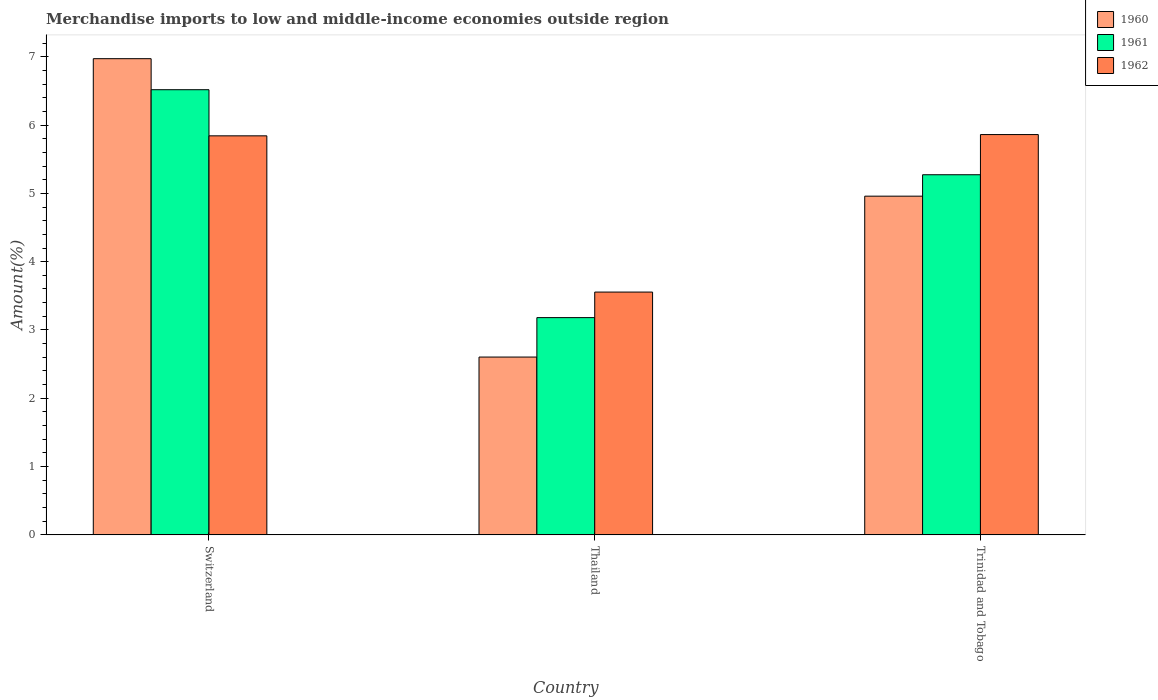How many bars are there on the 3rd tick from the right?
Ensure brevity in your answer.  3. What is the label of the 1st group of bars from the left?
Your answer should be compact. Switzerland. What is the percentage of amount earned from merchandise imports in 1960 in Thailand?
Ensure brevity in your answer.  2.6. Across all countries, what is the maximum percentage of amount earned from merchandise imports in 1960?
Keep it short and to the point. 6.97. Across all countries, what is the minimum percentage of amount earned from merchandise imports in 1962?
Your answer should be compact. 3.55. In which country was the percentage of amount earned from merchandise imports in 1960 maximum?
Your answer should be compact. Switzerland. In which country was the percentage of amount earned from merchandise imports in 1961 minimum?
Provide a succinct answer. Thailand. What is the total percentage of amount earned from merchandise imports in 1960 in the graph?
Make the answer very short. 14.53. What is the difference between the percentage of amount earned from merchandise imports in 1961 in Switzerland and that in Thailand?
Your answer should be compact. 3.34. What is the difference between the percentage of amount earned from merchandise imports in 1960 in Switzerland and the percentage of amount earned from merchandise imports in 1962 in Trinidad and Tobago?
Make the answer very short. 1.11. What is the average percentage of amount earned from merchandise imports in 1960 per country?
Ensure brevity in your answer.  4.84. What is the difference between the percentage of amount earned from merchandise imports of/in 1961 and percentage of amount earned from merchandise imports of/in 1962 in Thailand?
Your answer should be compact. -0.37. What is the ratio of the percentage of amount earned from merchandise imports in 1960 in Switzerland to that in Trinidad and Tobago?
Provide a succinct answer. 1.41. What is the difference between the highest and the second highest percentage of amount earned from merchandise imports in 1961?
Ensure brevity in your answer.  -2.09. What is the difference between the highest and the lowest percentage of amount earned from merchandise imports in 1962?
Give a very brief answer. 2.31. Is the sum of the percentage of amount earned from merchandise imports in 1962 in Thailand and Trinidad and Tobago greater than the maximum percentage of amount earned from merchandise imports in 1960 across all countries?
Keep it short and to the point. Yes. What does the 3rd bar from the left in Thailand represents?
Provide a short and direct response. 1962. Is it the case that in every country, the sum of the percentage of amount earned from merchandise imports in 1960 and percentage of amount earned from merchandise imports in 1962 is greater than the percentage of amount earned from merchandise imports in 1961?
Offer a very short reply. Yes. How many bars are there?
Offer a very short reply. 9. Are all the bars in the graph horizontal?
Provide a succinct answer. No. How many countries are there in the graph?
Your answer should be compact. 3. What is the difference between two consecutive major ticks on the Y-axis?
Your answer should be compact. 1. Does the graph contain any zero values?
Ensure brevity in your answer.  No. Where does the legend appear in the graph?
Provide a succinct answer. Top right. How many legend labels are there?
Ensure brevity in your answer.  3. How are the legend labels stacked?
Provide a short and direct response. Vertical. What is the title of the graph?
Provide a succinct answer. Merchandise imports to low and middle-income economies outside region. Does "1960" appear as one of the legend labels in the graph?
Your response must be concise. Yes. What is the label or title of the Y-axis?
Give a very brief answer. Amount(%). What is the Amount(%) of 1960 in Switzerland?
Provide a short and direct response. 6.97. What is the Amount(%) in 1961 in Switzerland?
Provide a short and direct response. 6.52. What is the Amount(%) of 1962 in Switzerland?
Offer a very short reply. 5.84. What is the Amount(%) of 1960 in Thailand?
Offer a terse response. 2.6. What is the Amount(%) in 1961 in Thailand?
Provide a succinct answer. 3.18. What is the Amount(%) of 1962 in Thailand?
Your answer should be very brief. 3.55. What is the Amount(%) in 1960 in Trinidad and Tobago?
Give a very brief answer. 4.96. What is the Amount(%) in 1961 in Trinidad and Tobago?
Offer a very short reply. 5.27. What is the Amount(%) in 1962 in Trinidad and Tobago?
Offer a very short reply. 5.86. Across all countries, what is the maximum Amount(%) of 1960?
Your answer should be very brief. 6.97. Across all countries, what is the maximum Amount(%) in 1961?
Offer a terse response. 6.52. Across all countries, what is the maximum Amount(%) of 1962?
Your answer should be compact. 5.86. Across all countries, what is the minimum Amount(%) in 1960?
Offer a terse response. 2.6. Across all countries, what is the minimum Amount(%) of 1961?
Make the answer very short. 3.18. Across all countries, what is the minimum Amount(%) of 1962?
Offer a very short reply. 3.55. What is the total Amount(%) in 1960 in the graph?
Ensure brevity in your answer.  14.53. What is the total Amount(%) in 1961 in the graph?
Keep it short and to the point. 14.97. What is the total Amount(%) in 1962 in the graph?
Keep it short and to the point. 15.26. What is the difference between the Amount(%) in 1960 in Switzerland and that in Thailand?
Ensure brevity in your answer.  4.37. What is the difference between the Amount(%) in 1961 in Switzerland and that in Thailand?
Provide a succinct answer. 3.34. What is the difference between the Amount(%) of 1962 in Switzerland and that in Thailand?
Your answer should be compact. 2.29. What is the difference between the Amount(%) in 1960 in Switzerland and that in Trinidad and Tobago?
Provide a short and direct response. 2.01. What is the difference between the Amount(%) in 1961 in Switzerland and that in Trinidad and Tobago?
Provide a short and direct response. 1.25. What is the difference between the Amount(%) of 1962 in Switzerland and that in Trinidad and Tobago?
Offer a very short reply. -0.02. What is the difference between the Amount(%) in 1960 in Thailand and that in Trinidad and Tobago?
Ensure brevity in your answer.  -2.36. What is the difference between the Amount(%) in 1961 in Thailand and that in Trinidad and Tobago?
Offer a very short reply. -2.09. What is the difference between the Amount(%) in 1962 in Thailand and that in Trinidad and Tobago?
Provide a short and direct response. -2.31. What is the difference between the Amount(%) in 1960 in Switzerland and the Amount(%) in 1961 in Thailand?
Provide a succinct answer. 3.79. What is the difference between the Amount(%) of 1960 in Switzerland and the Amount(%) of 1962 in Thailand?
Give a very brief answer. 3.42. What is the difference between the Amount(%) in 1961 in Switzerland and the Amount(%) in 1962 in Thailand?
Provide a short and direct response. 2.96. What is the difference between the Amount(%) in 1960 in Switzerland and the Amount(%) in 1961 in Trinidad and Tobago?
Your answer should be compact. 1.7. What is the difference between the Amount(%) in 1960 in Switzerland and the Amount(%) in 1962 in Trinidad and Tobago?
Offer a very short reply. 1.11. What is the difference between the Amount(%) in 1961 in Switzerland and the Amount(%) in 1962 in Trinidad and Tobago?
Make the answer very short. 0.66. What is the difference between the Amount(%) in 1960 in Thailand and the Amount(%) in 1961 in Trinidad and Tobago?
Your answer should be very brief. -2.67. What is the difference between the Amount(%) in 1960 in Thailand and the Amount(%) in 1962 in Trinidad and Tobago?
Your answer should be very brief. -3.26. What is the difference between the Amount(%) in 1961 in Thailand and the Amount(%) in 1962 in Trinidad and Tobago?
Provide a succinct answer. -2.68. What is the average Amount(%) in 1960 per country?
Ensure brevity in your answer.  4.84. What is the average Amount(%) of 1961 per country?
Keep it short and to the point. 4.99. What is the average Amount(%) in 1962 per country?
Ensure brevity in your answer.  5.09. What is the difference between the Amount(%) in 1960 and Amount(%) in 1961 in Switzerland?
Provide a succinct answer. 0.45. What is the difference between the Amount(%) in 1960 and Amount(%) in 1962 in Switzerland?
Provide a succinct answer. 1.13. What is the difference between the Amount(%) of 1961 and Amount(%) of 1962 in Switzerland?
Make the answer very short. 0.68. What is the difference between the Amount(%) of 1960 and Amount(%) of 1961 in Thailand?
Offer a terse response. -0.58. What is the difference between the Amount(%) of 1960 and Amount(%) of 1962 in Thailand?
Offer a very short reply. -0.95. What is the difference between the Amount(%) in 1961 and Amount(%) in 1962 in Thailand?
Offer a very short reply. -0.37. What is the difference between the Amount(%) in 1960 and Amount(%) in 1961 in Trinidad and Tobago?
Ensure brevity in your answer.  -0.31. What is the difference between the Amount(%) in 1960 and Amount(%) in 1962 in Trinidad and Tobago?
Your answer should be very brief. -0.9. What is the difference between the Amount(%) of 1961 and Amount(%) of 1962 in Trinidad and Tobago?
Your answer should be compact. -0.59. What is the ratio of the Amount(%) of 1960 in Switzerland to that in Thailand?
Ensure brevity in your answer.  2.68. What is the ratio of the Amount(%) of 1961 in Switzerland to that in Thailand?
Your response must be concise. 2.05. What is the ratio of the Amount(%) of 1962 in Switzerland to that in Thailand?
Give a very brief answer. 1.64. What is the ratio of the Amount(%) of 1960 in Switzerland to that in Trinidad and Tobago?
Keep it short and to the point. 1.41. What is the ratio of the Amount(%) of 1961 in Switzerland to that in Trinidad and Tobago?
Your response must be concise. 1.24. What is the ratio of the Amount(%) of 1962 in Switzerland to that in Trinidad and Tobago?
Your answer should be compact. 1. What is the ratio of the Amount(%) in 1960 in Thailand to that in Trinidad and Tobago?
Make the answer very short. 0.53. What is the ratio of the Amount(%) of 1961 in Thailand to that in Trinidad and Tobago?
Make the answer very short. 0.6. What is the ratio of the Amount(%) of 1962 in Thailand to that in Trinidad and Tobago?
Offer a very short reply. 0.61. What is the difference between the highest and the second highest Amount(%) in 1960?
Make the answer very short. 2.01. What is the difference between the highest and the second highest Amount(%) of 1961?
Keep it short and to the point. 1.25. What is the difference between the highest and the second highest Amount(%) in 1962?
Ensure brevity in your answer.  0.02. What is the difference between the highest and the lowest Amount(%) of 1960?
Your response must be concise. 4.37. What is the difference between the highest and the lowest Amount(%) in 1961?
Your answer should be compact. 3.34. What is the difference between the highest and the lowest Amount(%) in 1962?
Give a very brief answer. 2.31. 